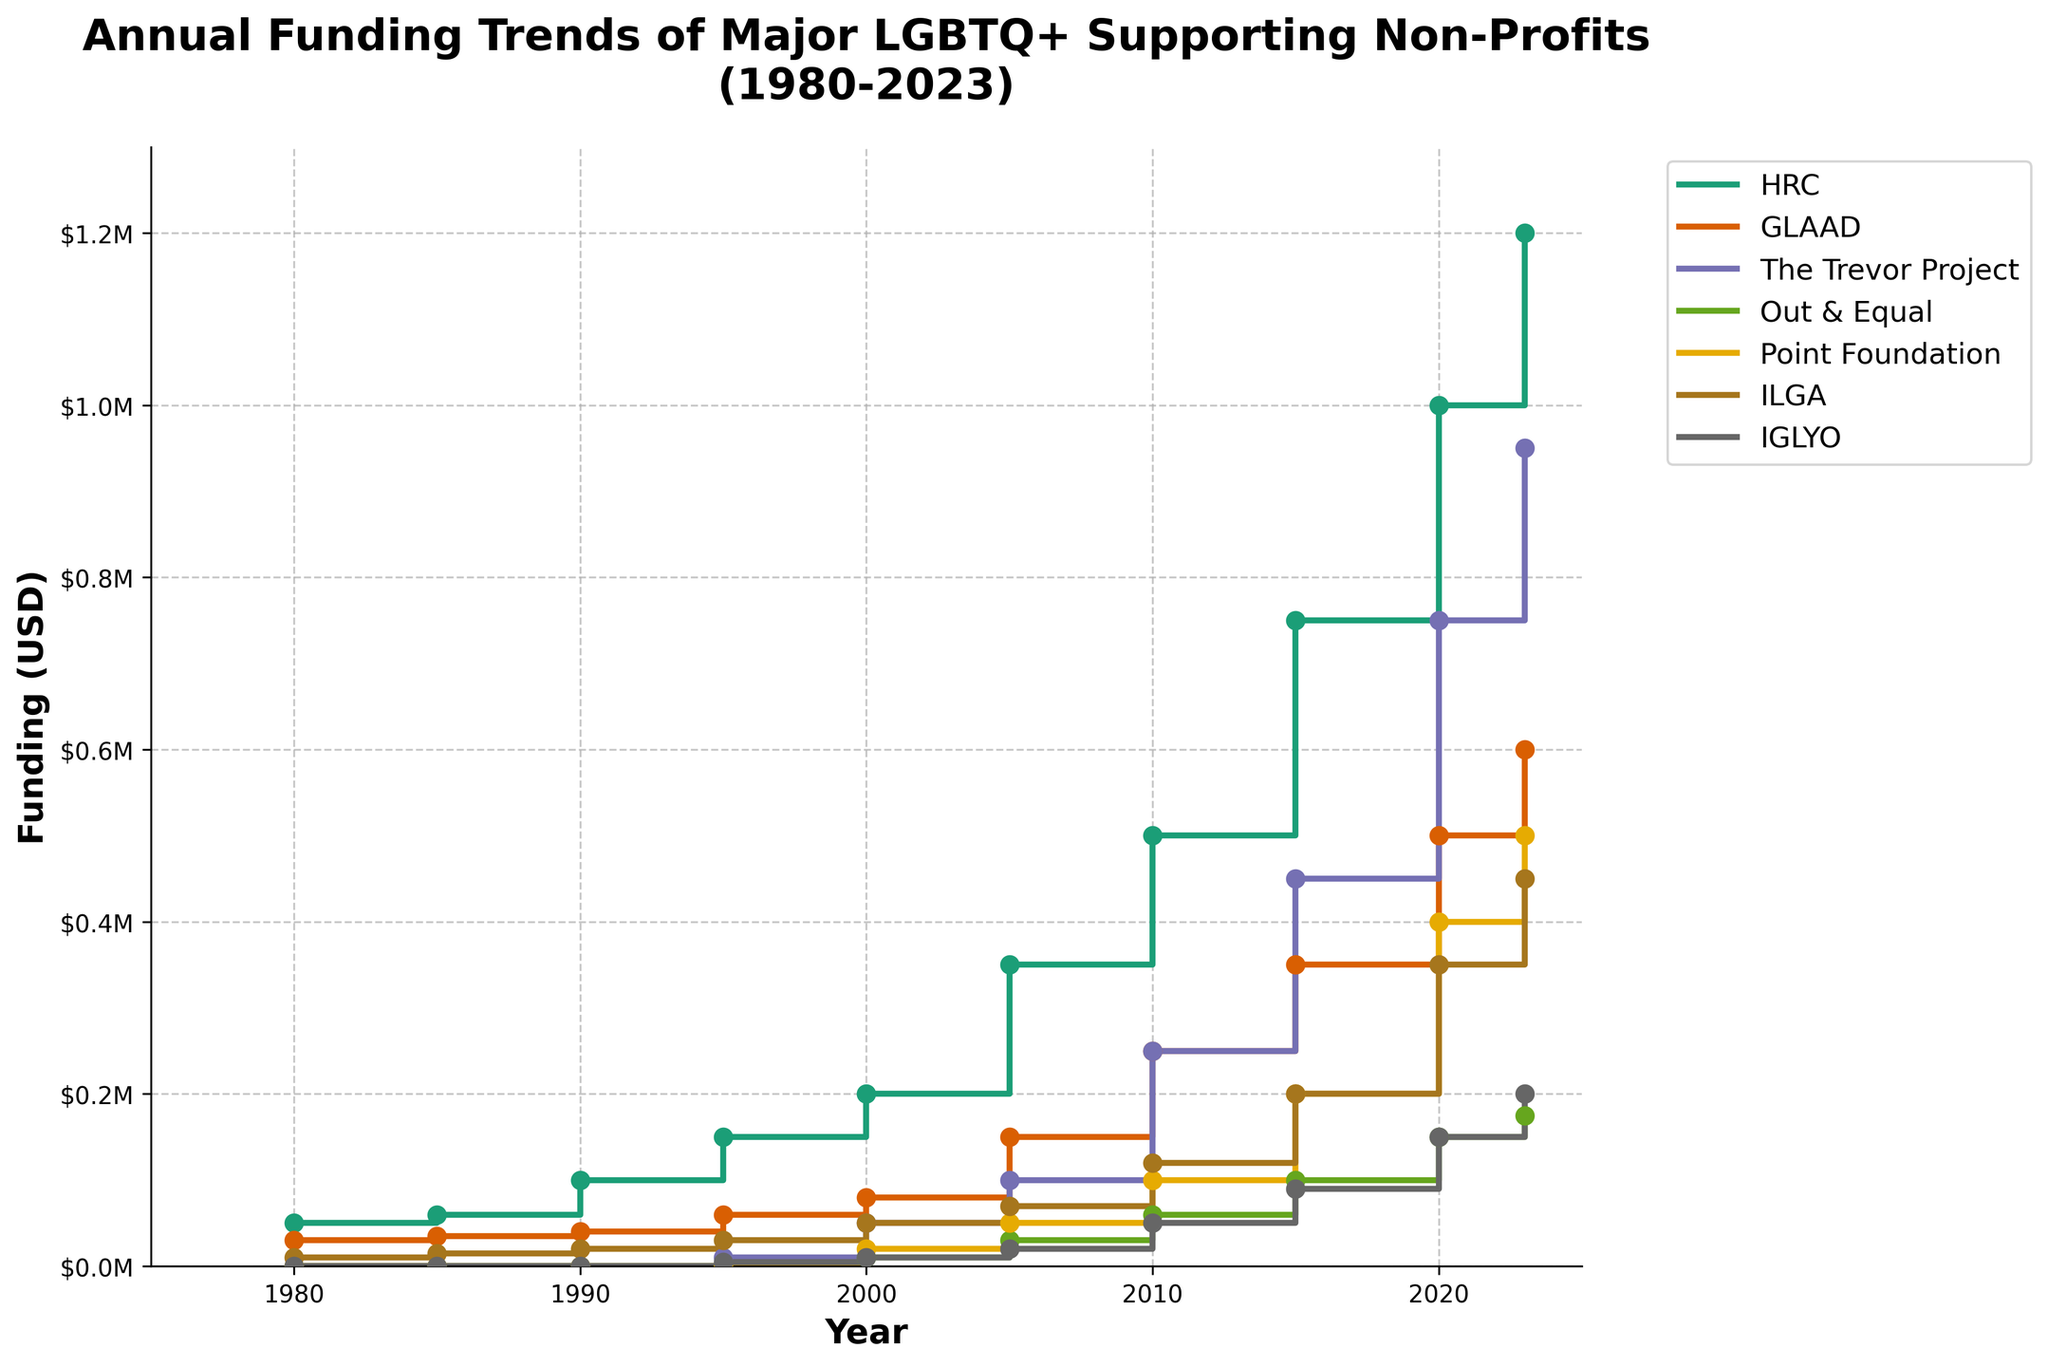What is the title of the plot? The title of the plot is usually displayed at the top of the figure.
Answer: Annual Funding Trends of Major LGBTQ+ Supporting Non-Profits (1980-2023) Which organization had zero funding in 1980? By looking at the y-axis values and the stair plot lines, you can identify that "The Trevor Project," "Out & Equal," "Point Foundation," and "IGLYO" had zero funding in 1980.
Answer: The Trevor Project, Out & Equal, Point Foundation, IGLYO How many organizations are tracked in this plot? The plot visually represents different colored lines, each corresponding to an organization. Counting them provides the answer.
Answer: 7 Which organization had the highest funding in 2023? Check the data points on the y-axis for each organization at the year 2023. The highest point corresponds to the organization with the highest funding.
Answer: HRC How much more funding did HRC receive in 2023 compared to 1980? Look at the funding values for HRC in 2023 and 1980. Subtract the 1980 value from the 2023 value.
Answer: 1150000 USD Between 2000 and 2005, which organization saw the largest increase in funding? Check the change in funding values for each organization between 2000 and 2005. Calculate the differences and compare them.
Answer: HRC What is the total funding received by The Trevor Project across all the years? Sum the funding amounts for The Trevor Project from 1995 to 2023 (as it had no funding before 1995).
Answer: 2550000 USD Which organization had the least increase in funding between 2010 and 2020? Find the funding amounts for each organization in 2010 and 2020, then calculate and compare the differences.
Answer: IGLYO When did Point Foundation start receiving funding according to the plot? Identify the year when the funding line for Point Foundation first appears above zero.
Answer: 2000 What was the average annual funding for GLAAD from 1980 to 2023? Sum the annual funding amounts for GLAAD from 1980 to 2023 and divide by the number of years.
Answer: 256818.18 USD 